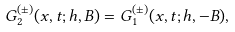<formula> <loc_0><loc_0><loc_500><loc_500>G _ { 2 } ^ { ( \pm ) } ( x , t ; h , B ) = G _ { 1 } ^ { ( \pm ) } ( x , t ; h , - B ) ,</formula> 